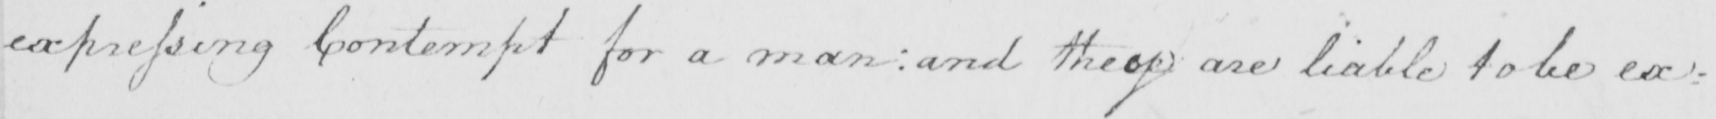Please provide the text content of this handwritten line. expressing Contempt for a man :  and they are liable to be ex= 